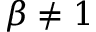<formula> <loc_0><loc_0><loc_500><loc_500>\beta \neq 1</formula> 